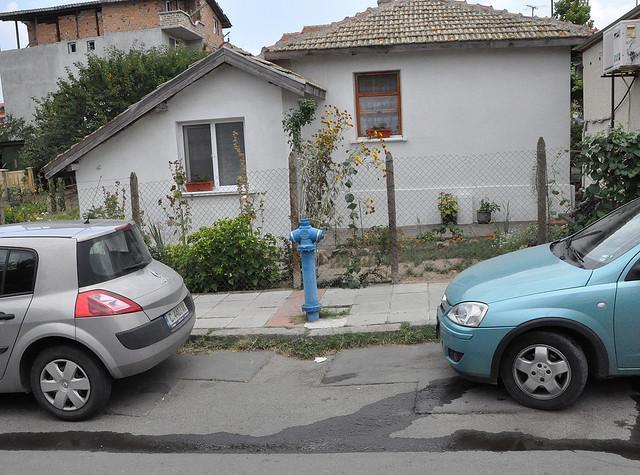How many stories is the brown house?
Give a very brief answer. 2. How many cars are visible?
Give a very brief answer. 2. How many orange cups are on the table?
Give a very brief answer. 0. 